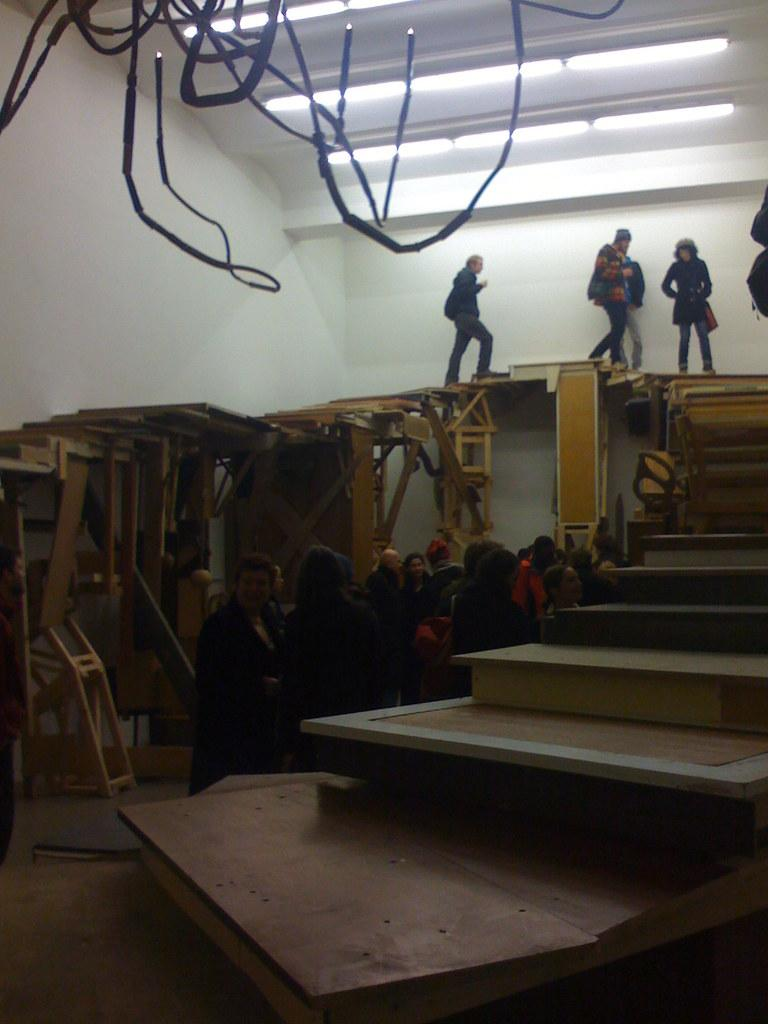Who or what is present in the image? There are people in the image. What architectural feature can be seen in the image? There are stairs in the image. What is visible in the background of the image? There is a wall in the background of the image. What can be seen at the top of the image? There are lights and wires at the top of the image. How many horses are present in the image? There are no horses present in the image. Can you describe the sound of someone sneezing in the image? There is no indication of anyone sneezing in the image, so it cannot be described. 